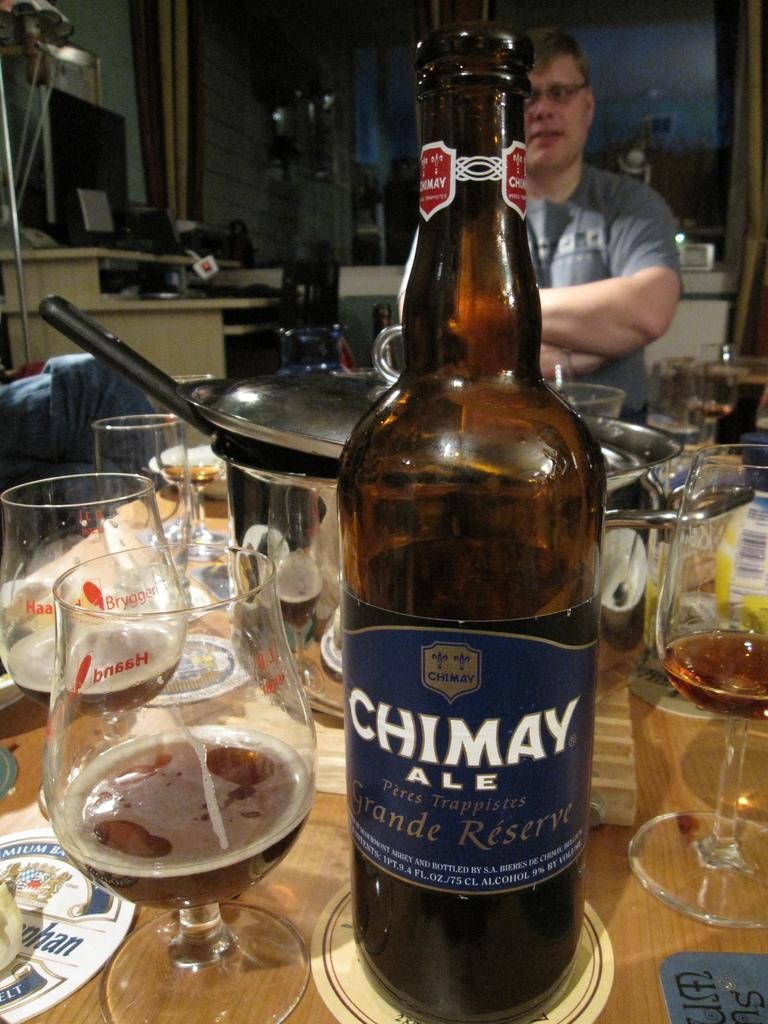What type of beverage container is present in the image? There is a wine bottle in the image. What is the wine bottle's contents being served in? There is a wine glass in the image, which contains wine. What other object is present in the image that is related to the wine? There is a vessel in the image, and it contains a spoon. Who is present in the image? There is a man standing in the image. Is there a coach visible in the image? No, there is no coach present in the image. Is the man in the image walking through a rainstorm? No, there is no rainstorm depicted in the image, and the man's actions are not described. 